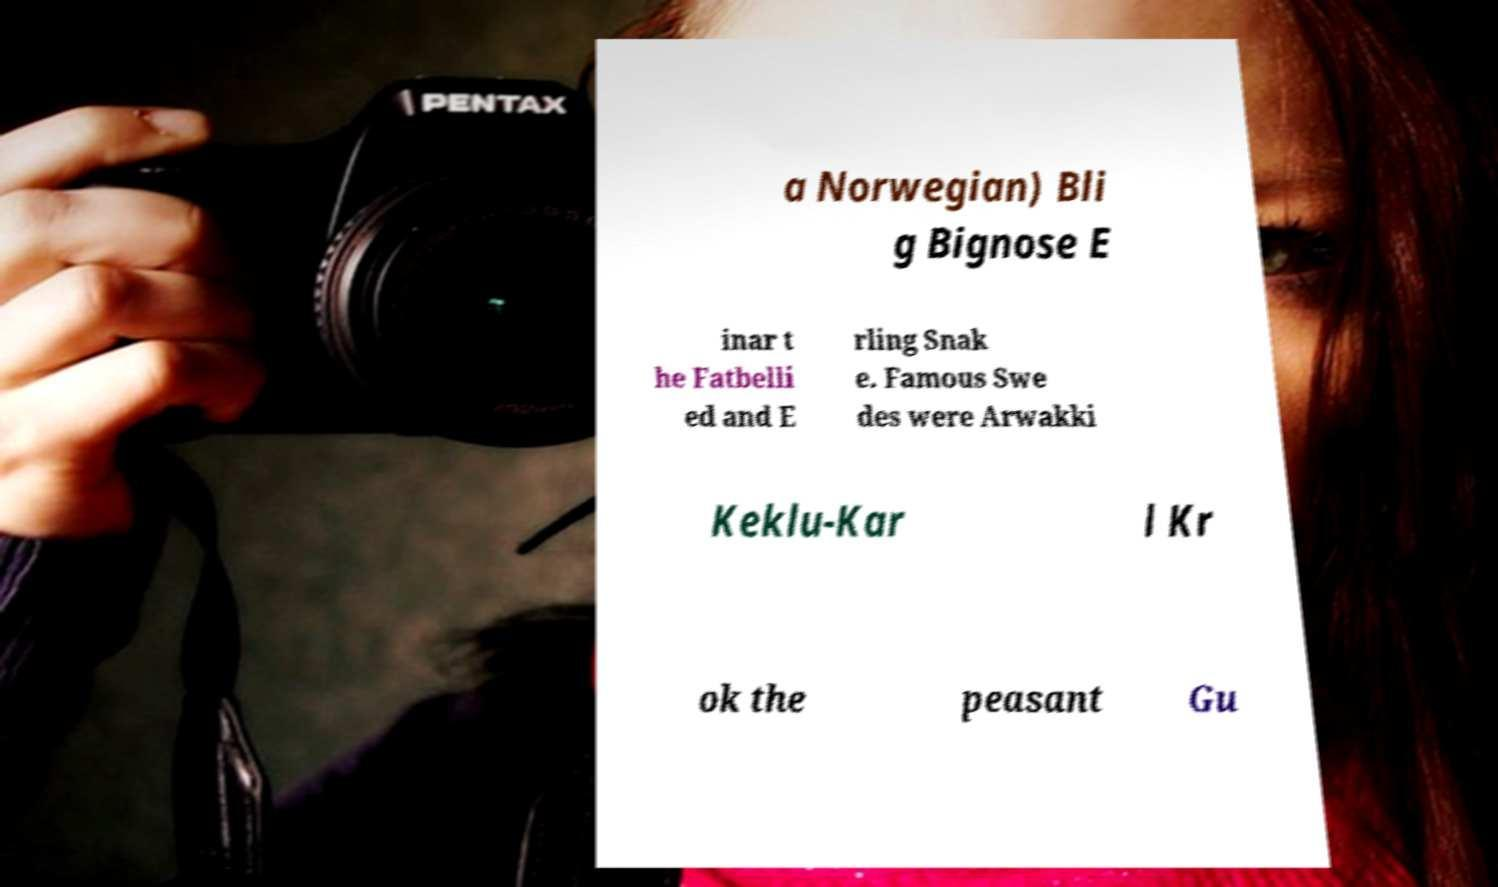Please identify and transcribe the text found in this image. a Norwegian) Bli g Bignose E inar t he Fatbelli ed and E rling Snak e. Famous Swe des were Arwakki Keklu-Kar l Kr ok the peasant Gu 